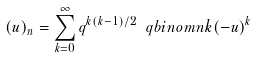<formula> <loc_0><loc_0><loc_500><loc_500>( u ) _ { n } = \sum _ { k = 0 } ^ { \infty } q ^ { k ( k - 1 ) / 2 } \ q b i n o m { n } { k } ( - u ) ^ { k }</formula> 